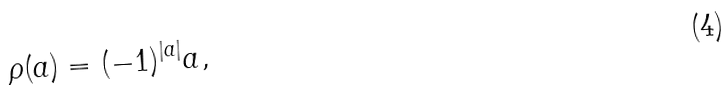<formula> <loc_0><loc_0><loc_500><loc_500>\rho ( a ) = ( - 1 ) ^ { | a | } a ,</formula> 